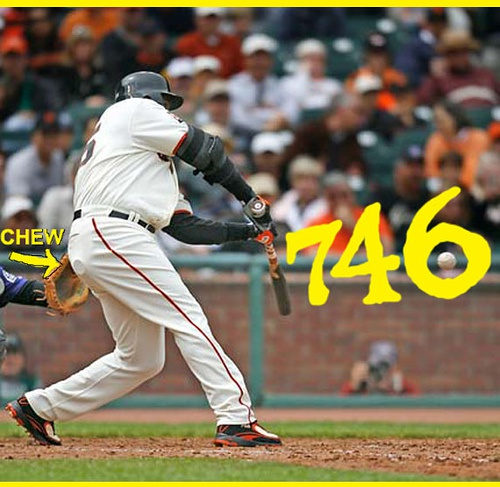Describe the objects in this image and their specific colors. I can see people in yellow, black, gray, and maroon tones, people in yellow, lightgray, darkgray, black, and gray tones, people in yellow, darkgray, gray, and lightgray tones, people in yellow, gray, darkgray, black, and maroon tones, and people in yellow, maroon, brown, black, and darkgray tones in this image. 